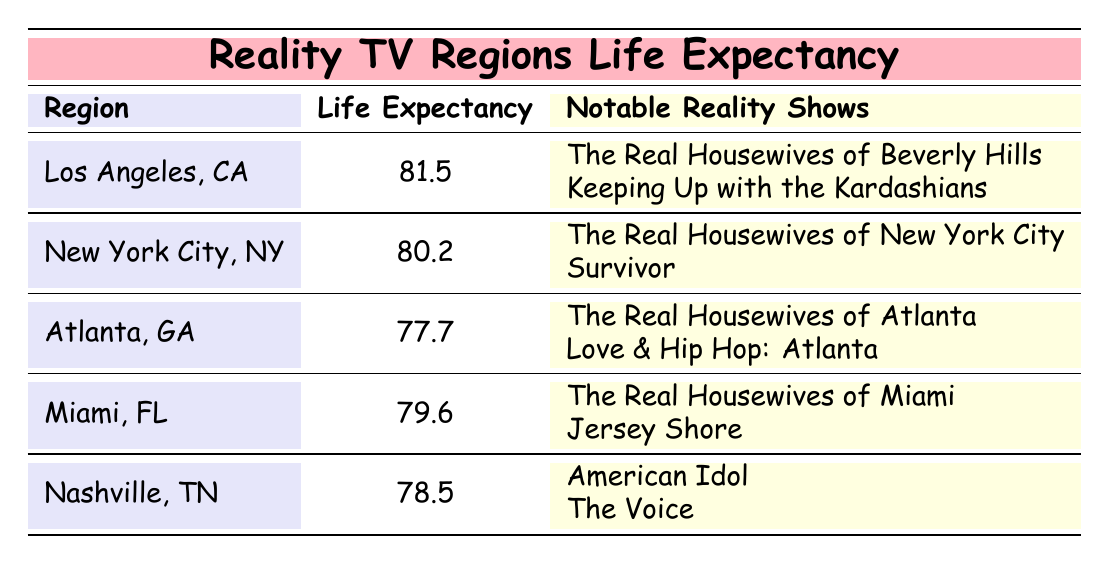What is the life expectancy in Los Angeles, California? The table lists the life expectancy for Los Angeles, California as 81.5 years.
Answer: 81.5 Which region has a life expectancy of 79.6 years? The table indicates that Miami, Florida has a life expectancy of 79.6 years.
Answer: Miami, Florida Is the life expectancy in Nashville, Tennessee higher than that in Atlanta, Georgia? Nashville has a life expectancy of 78.5 years, while Atlanta has a life expectancy of 77.7 years. Since 78.5 is greater than 77.7, the answer is yes.
Answer: Yes What is the average life expectancy of the regions listed in the table? Sum the life expectancy values: 81.5 + 80.2 + 77.7 + 79.6 + 78.5 = 397.5. There are 5 regions, so the average is 397.5 divided by 5, which gives 79.5.
Answer: 79.5 Does New York City have more notable reality shows compared to Nashville? New York City has two notable reality shows listed, while Nashville also has two notable shows. Therefore, New York City does not have more.
Answer: No 